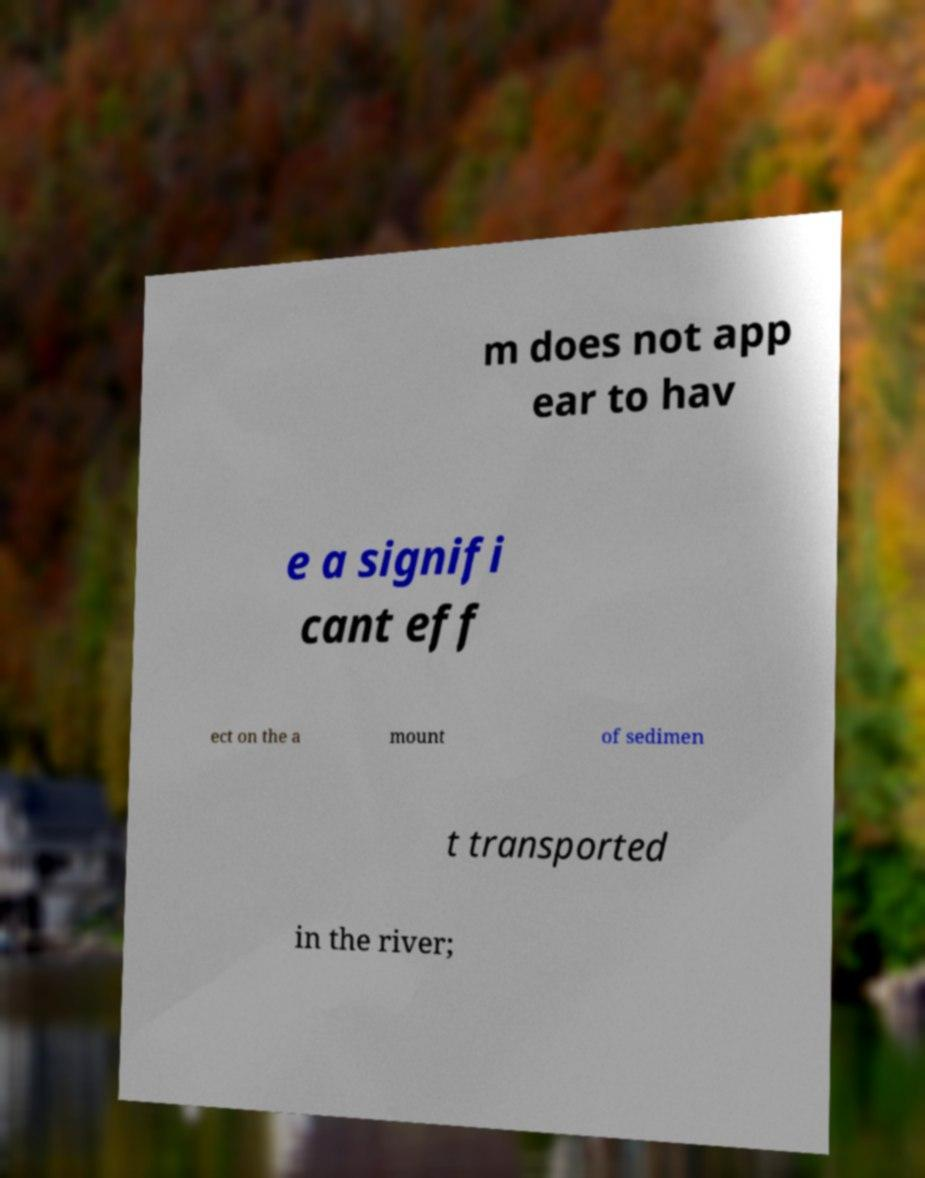Could you extract and type out the text from this image? m does not app ear to hav e a signifi cant eff ect on the a mount of sedimen t transported in the river; 